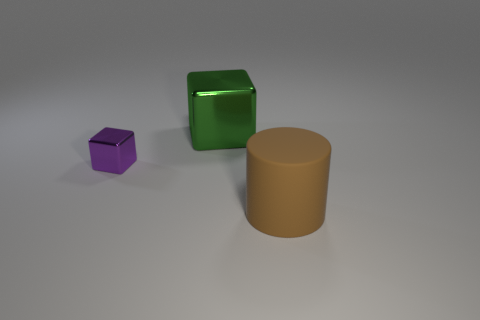Are there any other things that are the same size as the purple block?
Your answer should be very brief. No. Is there anything else that has the same material as the cylinder?
Offer a terse response. No. There is a big object to the left of the big brown rubber object; how many purple metal things are to the right of it?
Make the answer very short. 0. How many gray objects are small shiny blocks or cubes?
Your answer should be very brief. 0. There is a big thing on the left side of the big thing that is to the right of the big object that is to the left of the brown cylinder; what is its shape?
Provide a short and direct response. Cube. What is the color of the cube that is the same size as the brown matte cylinder?
Your answer should be very brief. Green. How many big brown matte things are the same shape as the green shiny object?
Ensure brevity in your answer.  0. There is a purple metallic object; is it the same size as the object in front of the purple thing?
Provide a short and direct response. No. What shape is the big object behind the thing that is on the right side of the large green metal cube?
Offer a terse response. Cube. Is the number of matte things that are behind the large green shiny thing less than the number of small yellow matte cylinders?
Give a very brief answer. No. 